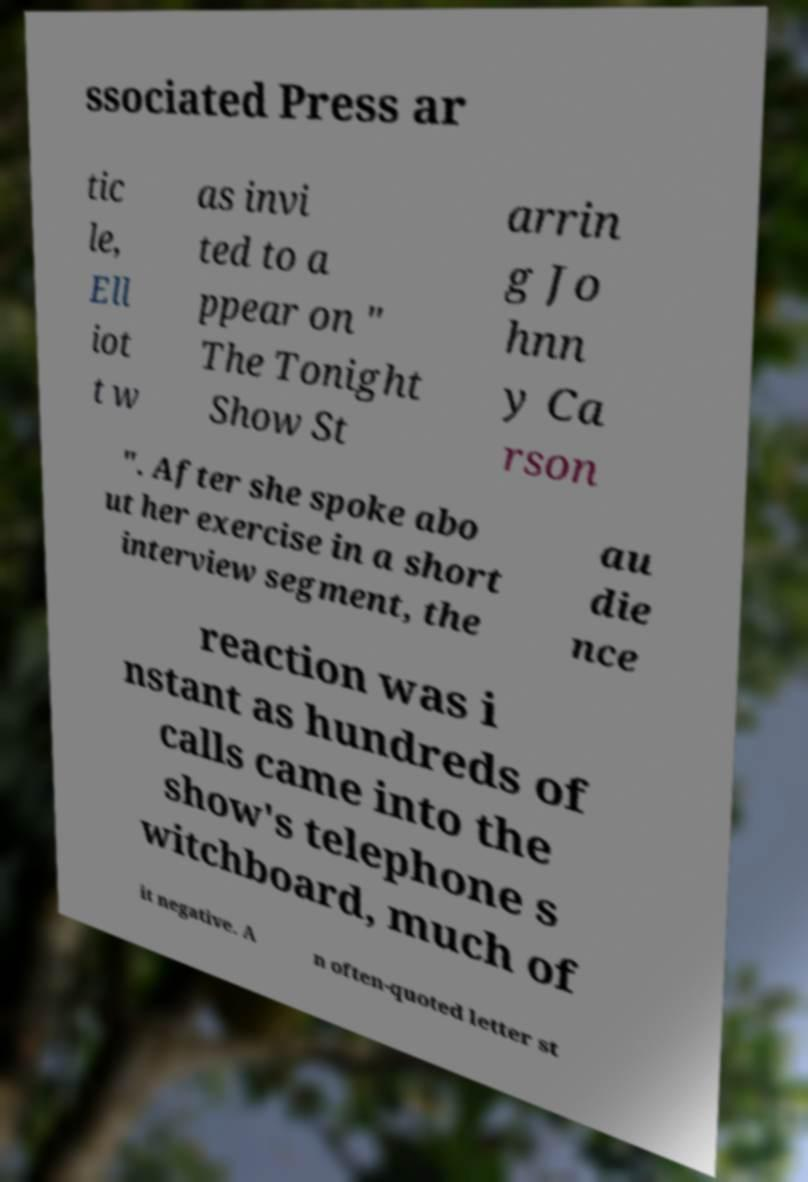Can you accurately transcribe the text from the provided image for me? ssociated Press ar tic le, Ell iot t w as invi ted to a ppear on " The Tonight Show St arrin g Jo hnn y Ca rson ". After she spoke abo ut her exercise in a short interview segment, the au die nce reaction was i nstant as hundreds of calls came into the show's telephone s witchboard, much of it negative. A n often-quoted letter st 